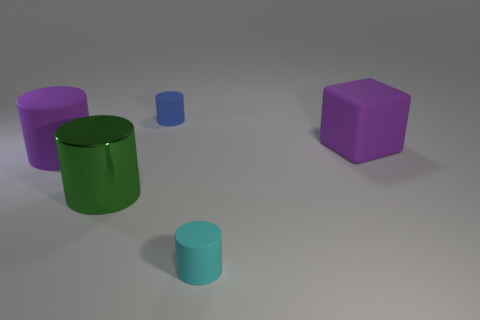Can you describe the colors and shapes present in this image? Certainly! The image shows a collection of geometric shapes with several appealing colors. There's a large green cylinder, a big purple cube, a small blue cylinder, and a smaller green cylinder. Their surfaces appear to have a matte finish, giving them a soft visual texture. 